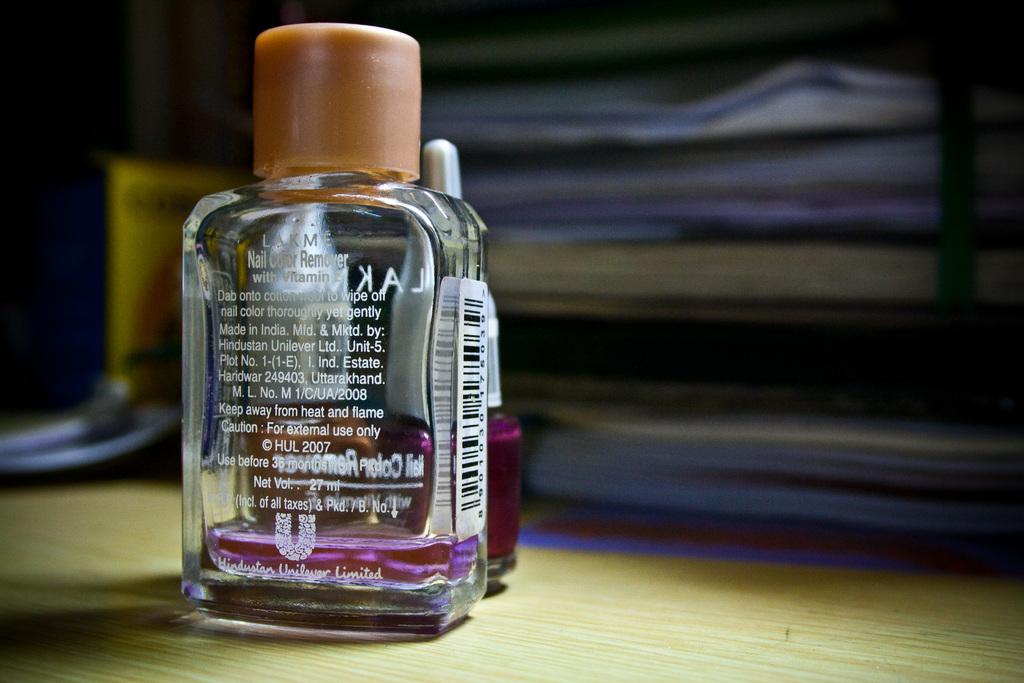What is in the bottle?
Give a very brief answer. Nail color remover. 